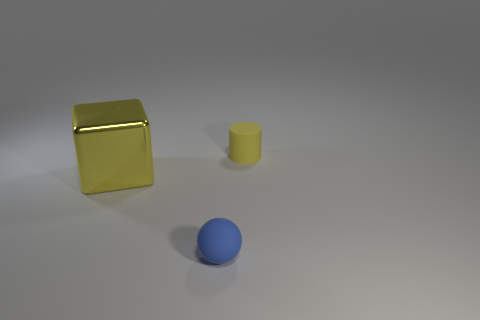Can you tell me what objects are present in this image? The image displays three objects: one small yellow cylinder, a larger yellow cube, and a blue sphere resting on a flat surface. Do the objects seem to be real or computer-generated? The objects appear to be computer-generated, given their perfect geometric shapes and the uniform lighting that lacks natural variances one would expect in a real-world setting. 